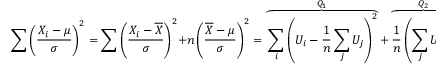<formula> <loc_0><loc_0><loc_500><loc_500>\sum \left ( { \frac { X _ { i } - \mu } { \sigma } } \right ) ^ { 2 } = \sum \left ( { \frac { X _ { i } - { \overline { X } } } { \sigma } } \right ) ^ { 2 } + n \left ( { \frac { { \overline { X } } - \mu } { \sigma } } \right ) ^ { 2 } = \overbrace { \sum _ { i } \left ( U _ { i } - { \frac { 1 } { n } } \sum _ { j } { U _ { j } } \right ) ^ { 2 } } ^ { Q _ { 1 } } + \overbrace { { \frac { 1 } { n } } \left ( \sum _ { j } { U _ { j } } \right ) ^ { 2 } } ^ { Q _ { 2 } } = Q _ { 1 } + Q _ { 2 } .</formula> 